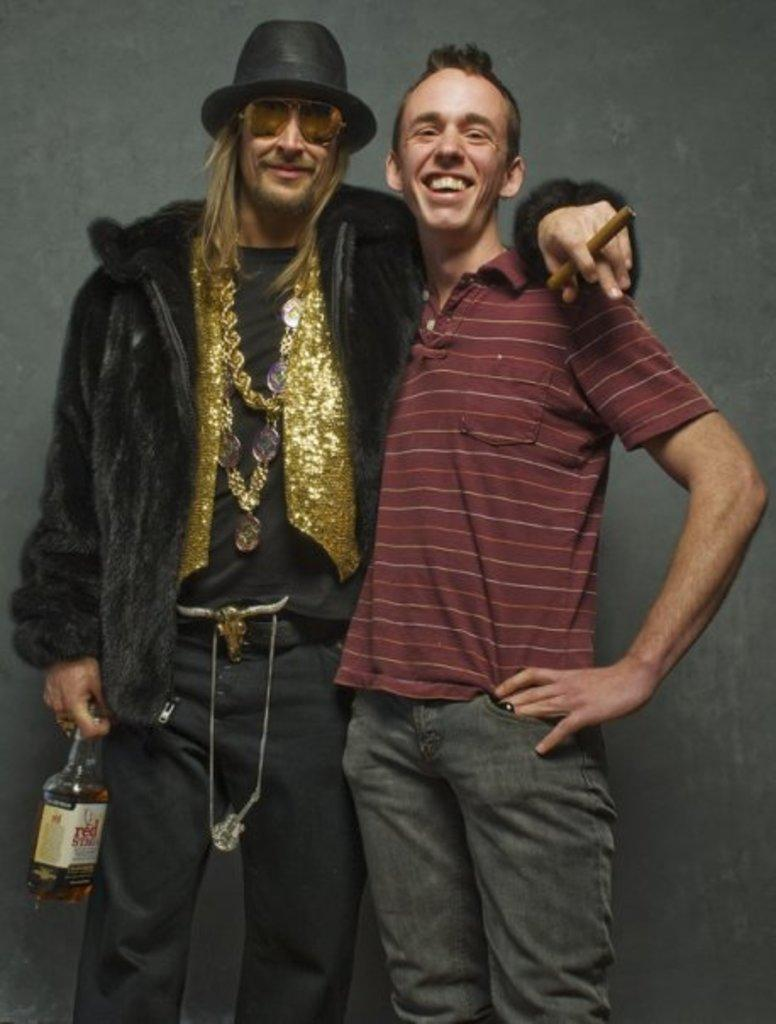How many people are in the image? There are two persons in the image. What is one person holding in the image? One person is holding a bottle. What protective gear is the person holding the bottle wearing? The person holding the bottle is wearing goggles. What type of headwear is the person holding the bottle wearing? The person holding the bottle is wearing a cap. What can be seen in the background of the image? There is a wall in the background of the image. What type of quartz can be seen in the jar on the bed in the image? There is no quartz, jar, or bed present in the image. 